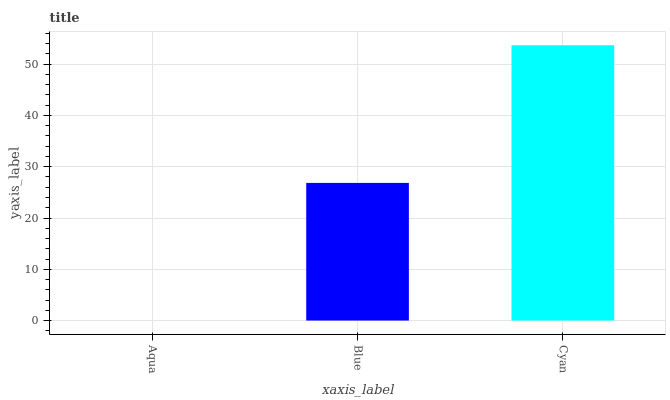Is Aqua the minimum?
Answer yes or no. Yes. Is Cyan the maximum?
Answer yes or no. Yes. Is Blue the minimum?
Answer yes or no. No. Is Blue the maximum?
Answer yes or no. No. Is Blue greater than Aqua?
Answer yes or no. Yes. Is Aqua less than Blue?
Answer yes or no. Yes. Is Aqua greater than Blue?
Answer yes or no. No. Is Blue less than Aqua?
Answer yes or no. No. Is Blue the high median?
Answer yes or no. Yes. Is Blue the low median?
Answer yes or no. Yes. Is Cyan the high median?
Answer yes or no. No. Is Cyan the low median?
Answer yes or no. No. 